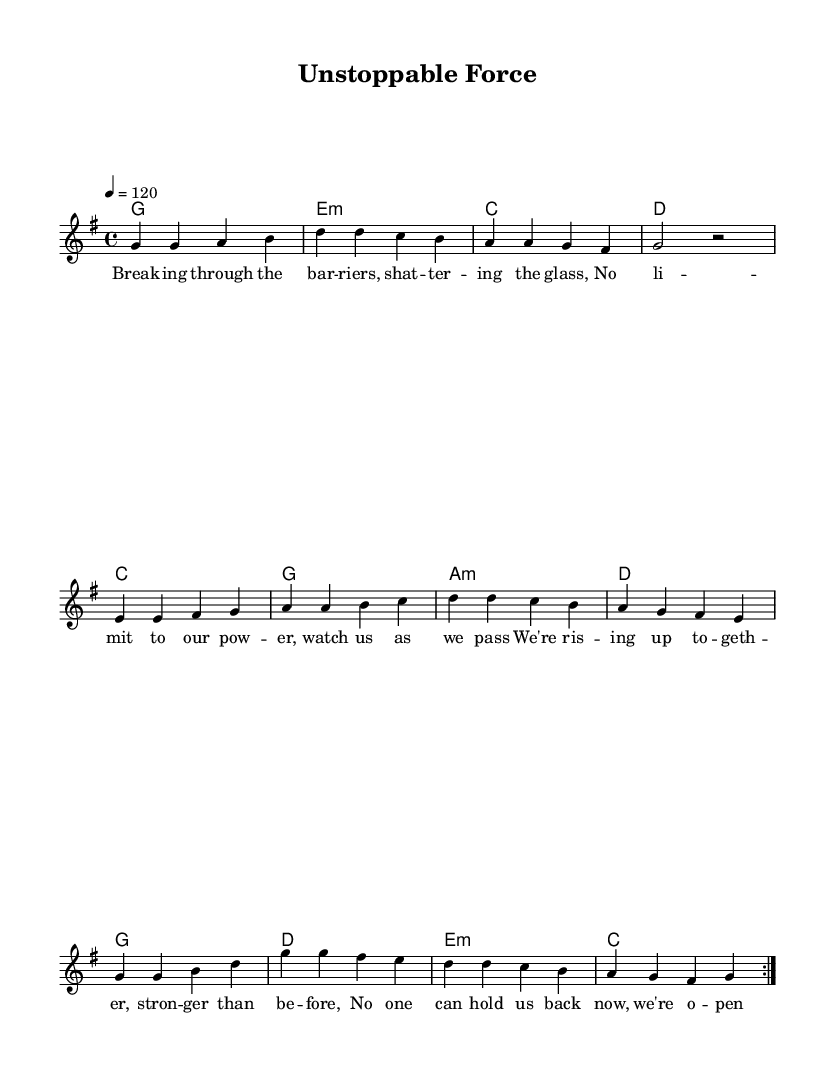What is the key signature of this music? The key signature shows one sharp, which indicates it is G major.
Answer: G major What is the time signature of this music? The time signature is represented by the top number in the given measure, which indicates how many beats are in each measure; here, it is 4/4.
Answer: 4/4 What is the tempo marking for this piece? The tempo marking indicates the speed of the piece; in this case, the marking '4 = 120' shows it’s at a moderate pace of 120 beats per minute.
Answer: 120 How many times is the verse repeated? The repeat symbol in the score indicates that the verse section is played two times, as shown by the "repeat volta 2" notation before the verse.
Answer: 2 What musical form does this piece follow? The structure of the music indicates it follows the common pop song format of Verse, Pre-Chorus, and Chorus, allowing for clear sections that promote lyrical storytelling.
Answer: Verse, Pre-Chorus, Chorus What is the lyrical theme of this piece? By examining the lyrics, the theme focuses on female empowerment and breaking barriers, as explicit in phrases like "breaking through the barriers" and "we are unstoppable".
Answer: Female empowerment How does the harmony progress during the chorus? The harmony during the chorus comprises four measures, with chords changing to support the melody; it moves from G major to D major to E minor and finally to C major, providing a sense of resolution.
Answer: G, D, E minor, C 